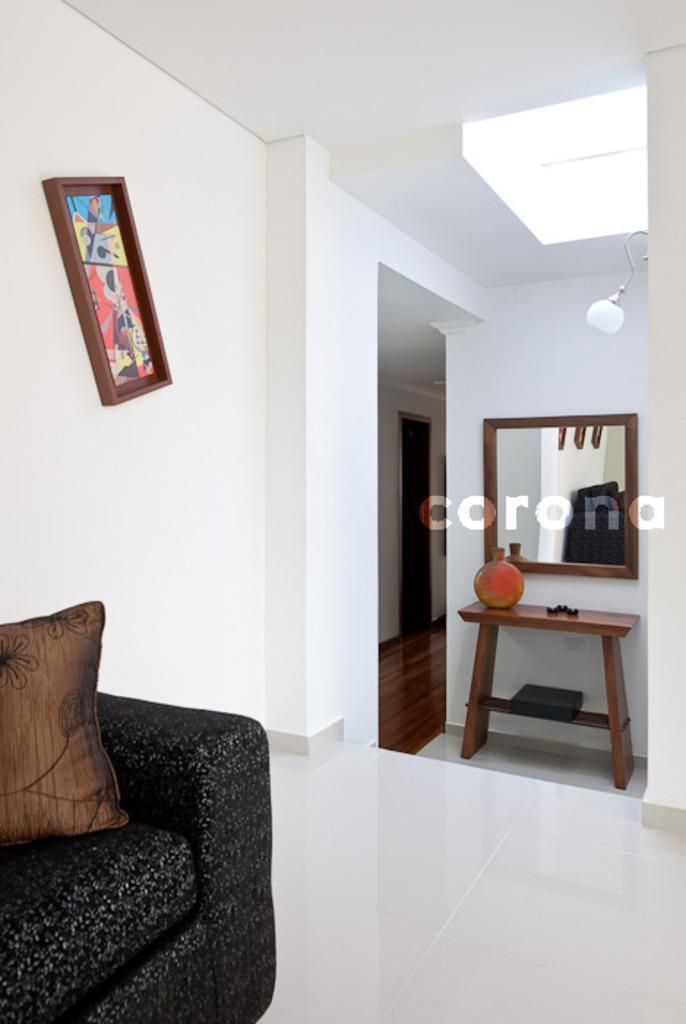Can you describe this image briefly? This is an inside view. On the left corner there is a couch, beside that there is a frame is attached to the wall. On the right side I can see a mirror below that there is a table. 